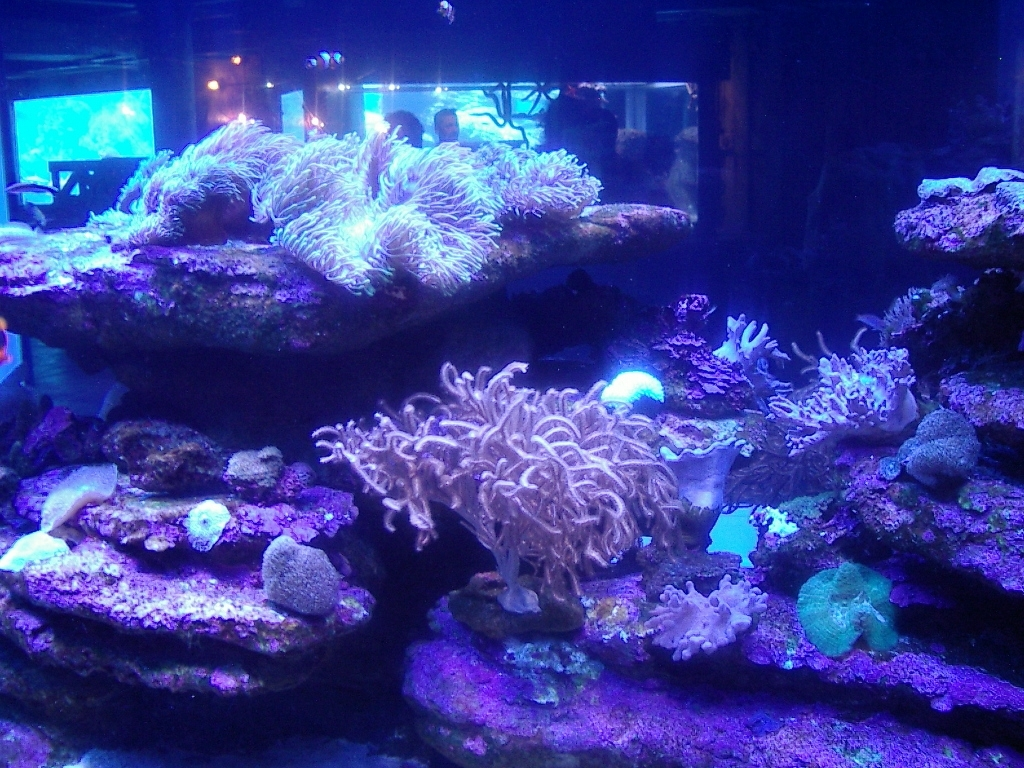Does the image suffer from any blur or motion blur? The image appears to have a slight blur, likely due to low lighting conditions and a long exposure, which are common in aquarium settings to avoid disturbing marine life. There is no discernible motion blur, suggesting that the photo was taken with a steady hand or a support. 